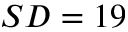<formula> <loc_0><loc_0><loc_500><loc_500>S D = 1 9</formula> 